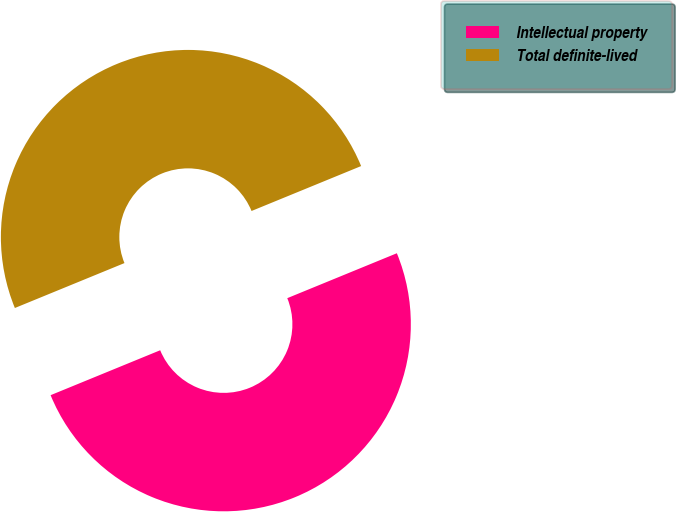Convert chart to OTSL. <chart><loc_0><loc_0><loc_500><loc_500><pie_chart><fcel>Intellectual property<fcel>Total definite-lived<nl><fcel>50.0%<fcel>50.0%<nl></chart> 